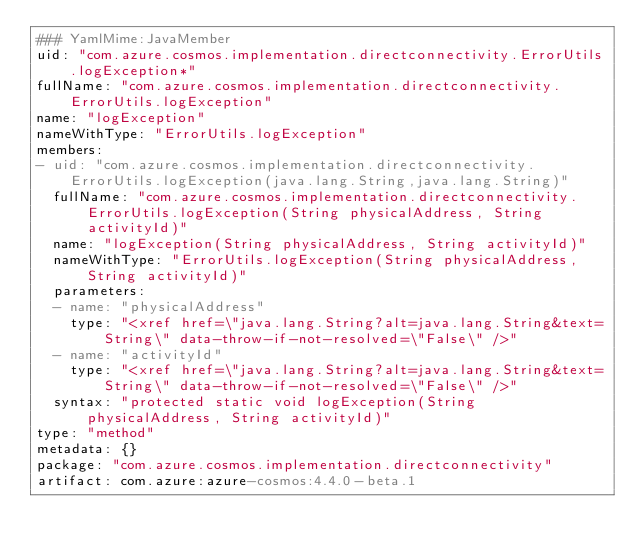<code> <loc_0><loc_0><loc_500><loc_500><_YAML_>### YamlMime:JavaMember
uid: "com.azure.cosmos.implementation.directconnectivity.ErrorUtils.logException*"
fullName: "com.azure.cosmos.implementation.directconnectivity.ErrorUtils.logException"
name: "logException"
nameWithType: "ErrorUtils.logException"
members:
- uid: "com.azure.cosmos.implementation.directconnectivity.ErrorUtils.logException(java.lang.String,java.lang.String)"
  fullName: "com.azure.cosmos.implementation.directconnectivity.ErrorUtils.logException(String physicalAddress, String activityId)"
  name: "logException(String physicalAddress, String activityId)"
  nameWithType: "ErrorUtils.logException(String physicalAddress, String activityId)"
  parameters:
  - name: "physicalAddress"
    type: "<xref href=\"java.lang.String?alt=java.lang.String&text=String\" data-throw-if-not-resolved=\"False\" />"
  - name: "activityId"
    type: "<xref href=\"java.lang.String?alt=java.lang.String&text=String\" data-throw-if-not-resolved=\"False\" />"
  syntax: "protected static void logException(String physicalAddress, String activityId)"
type: "method"
metadata: {}
package: "com.azure.cosmos.implementation.directconnectivity"
artifact: com.azure:azure-cosmos:4.4.0-beta.1
</code> 